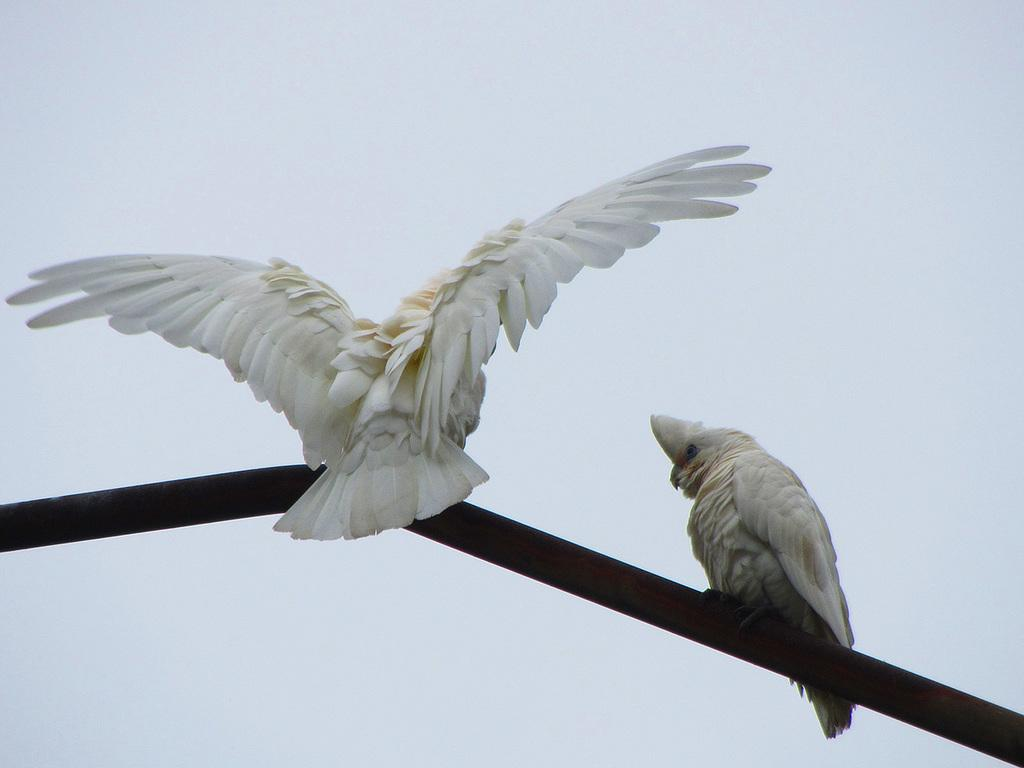What type of animals are in the image? There are two white color birds in the image. Where are the birds located? The birds are standing on a road. What is one of the birds doing in the image? One of the birds is stretching its wings. What can be seen in the background of the image? The sky is visible in the background of the image. How many toes can be seen on the birds in the image? The image does not show the toes of the birds, so it cannot be determined from the image. 